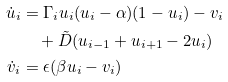<formula> <loc_0><loc_0><loc_500><loc_500>\dot { u } _ { i } & = \Gamma _ { i } u _ { i } ( u _ { i } - \alpha ) ( 1 - u _ { i } ) - v _ { i } \\ & \quad + \tilde { D } ( u _ { i - 1 } + u _ { i + 1 } - 2 u _ { i } ) \\ \dot { v } _ { i } & = \epsilon ( \beta u _ { i } - v _ { i } )</formula> 